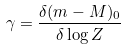Convert formula to latex. <formula><loc_0><loc_0><loc_500><loc_500>\gamma = \frac { \delta ( m - M ) _ { 0 } } { \delta \log Z }</formula> 